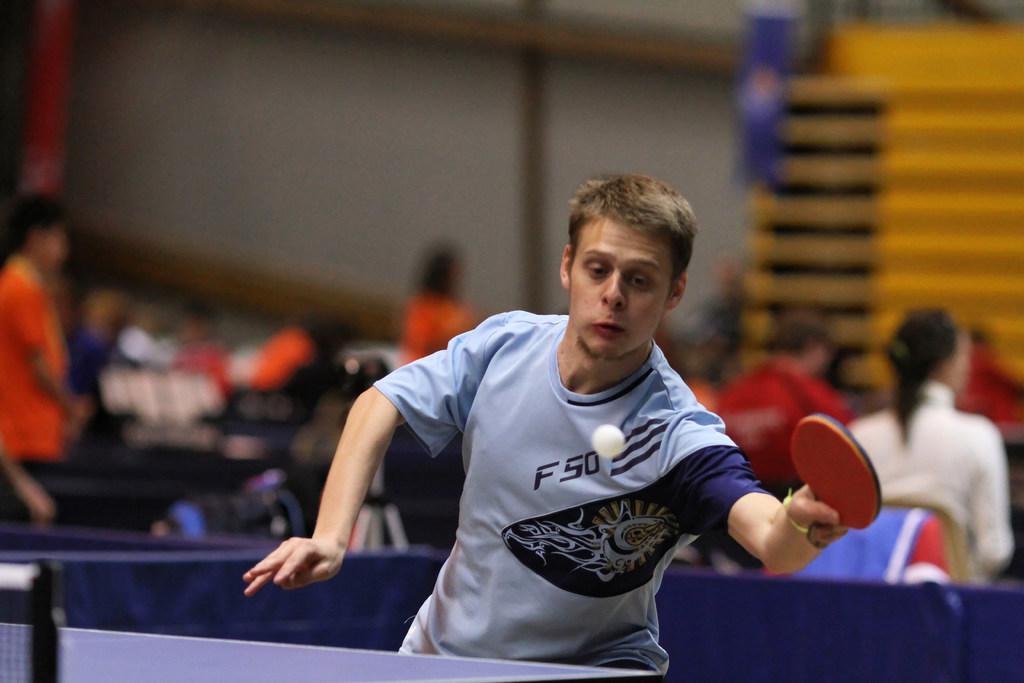What number is on the man's shirt?
Offer a very short reply. 50. 